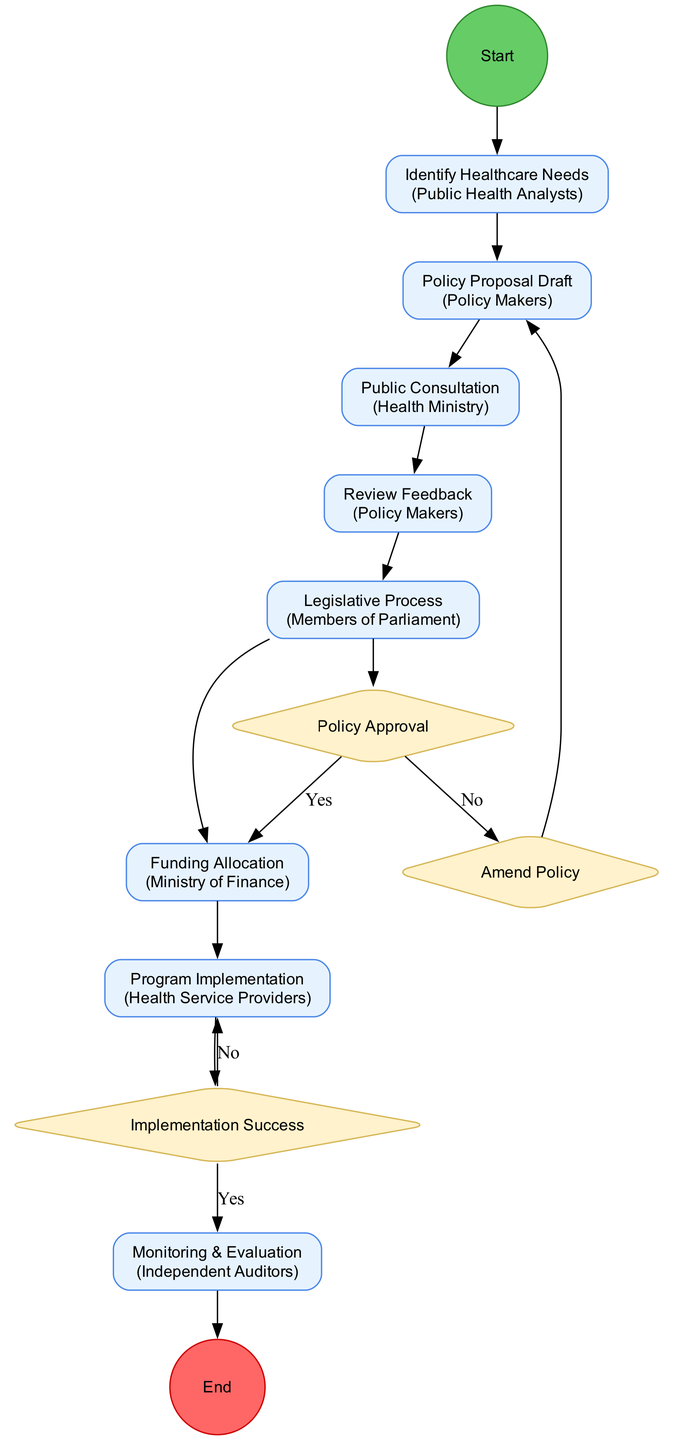What is the total number of activities in the diagram? The diagram includes eight activities listed under "Activities" in the data. Counting each listed activity results in a total of eight.
Answer: 8 Who is responsible for the "Policy Proposal Draft"? The diagram indicates that "Policy Makers" is the actor associated with the "Policy Proposal Draft" activity.
Answer: Policy Makers Which activity comes after "Public Consultation"? Following "Public Consultation" in the sequential order of activities is "Review Feedback."
Answer: Review Feedback How many decision nodes are present in the diagram? The "DecisionNodes" section of the data shows two decision nodes, "Policy Approval" and "Implementation Success."
Answer: 2 What happens if the policy is not approved? According to the "Policy Approval" decision, if the policy is not approved, the flow goes to "Amend Policy," indicating that revisions to the proposal must be made.
Answer: Amend Policy What is the final outcome after "Monitoring & Evaluation"? The final node in the flow is "End," which represents the conclusion of the process after "Monitoring & Evaluation."
Answer: End Which actor is responsible for "Funding Allocation"? The data specifies that "Ministry of Finance" is the actor assigned to the "Funding Allocation" activity.
Answer: Ministry of Finance How does the diagram indicate the relationship between "Legislative Process" and "Policy Approval"? The diagram shows an edge from "Legislative Process" to "Policy Approval," indicating that the proposal must be submitted to the legislature for evaluation before funding allocation.
Answer: Edge from Legislative Process to Policy Approval What action occurs if the implementation is successful? If the "Implementation Success" decision evaluates as successful, the next action indicated is "Monitoring & Evaluation."
Answer: Monitoring & Evaluation 